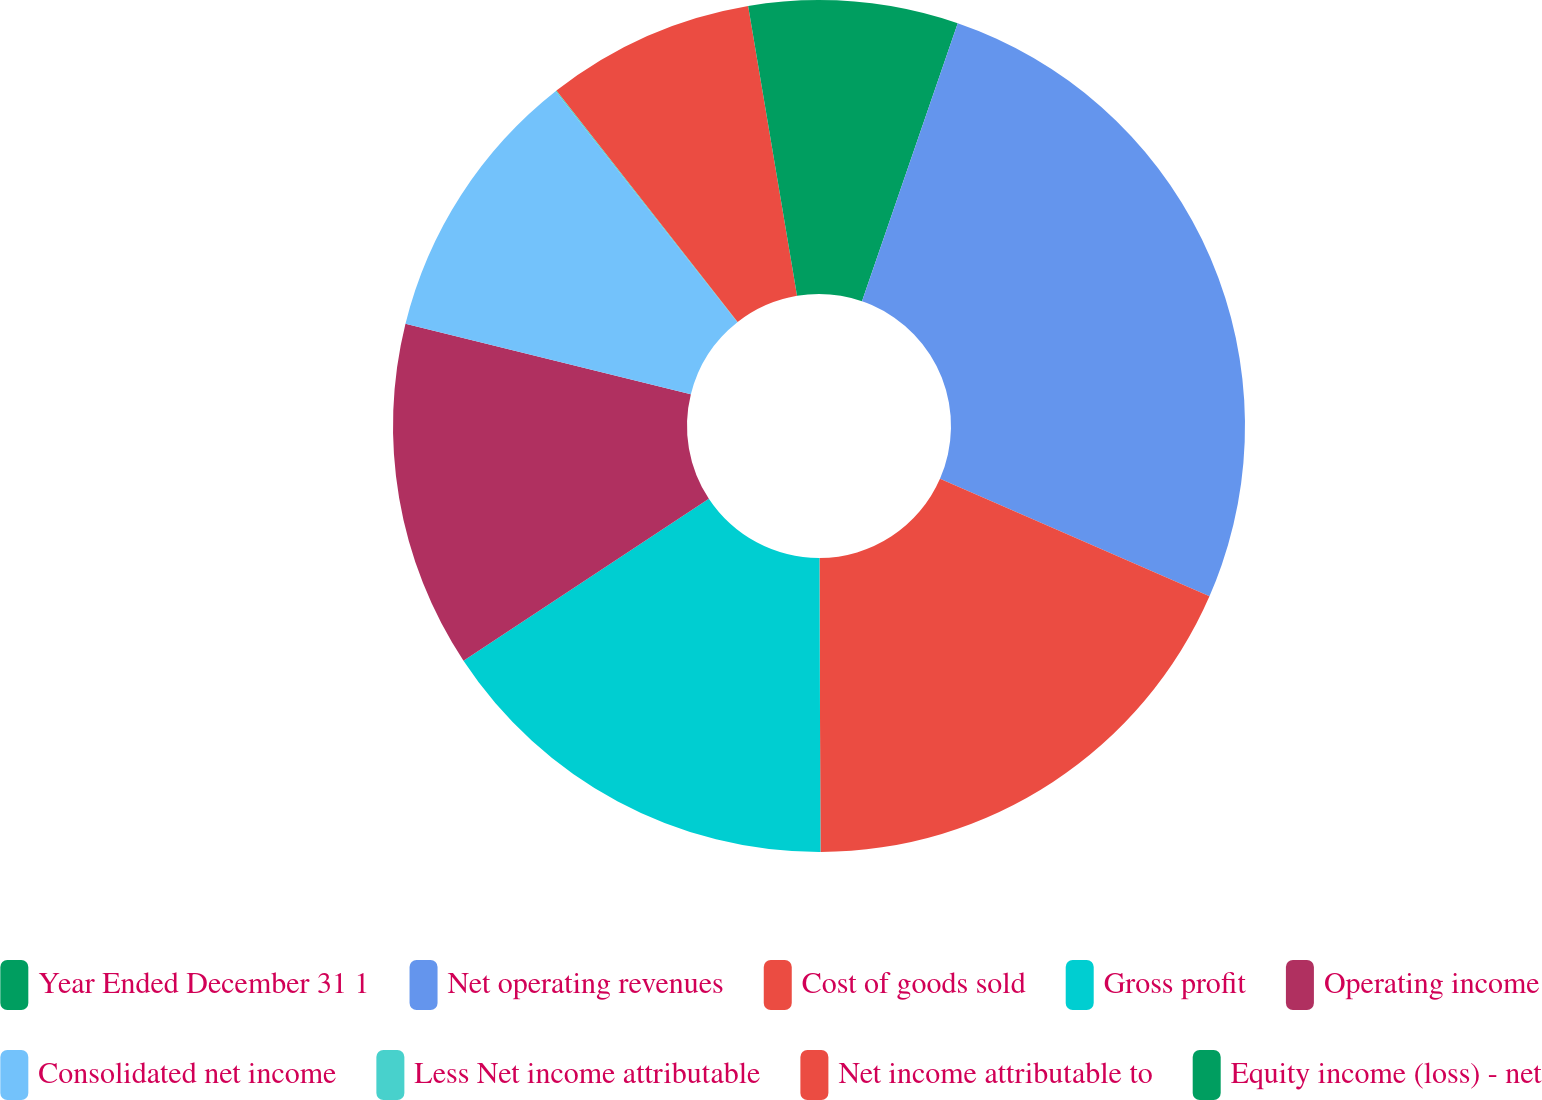Convert chart. <chart><loc_0><loc_0><loc_500><loc_500><pie_chart><fcel>Year Ended December 31 1<fcel>Net operating revenues<fcel>Cost of goods sold<fcel>Gross profit<fcel>Operating income<fcel>Consolidated net income<fcel>Less Net income attributable<fcel>Net income attributable to<fcel>Equity income (loss) - net<nl><fcel>5.28%<fcel>26.27%<fcel>18.4%<fcel>15.77%<fcel>13.15%<fcel>10.53%<fcel>0.04%<fcel>7.91%<fcel>2.66%<nl></chart> 